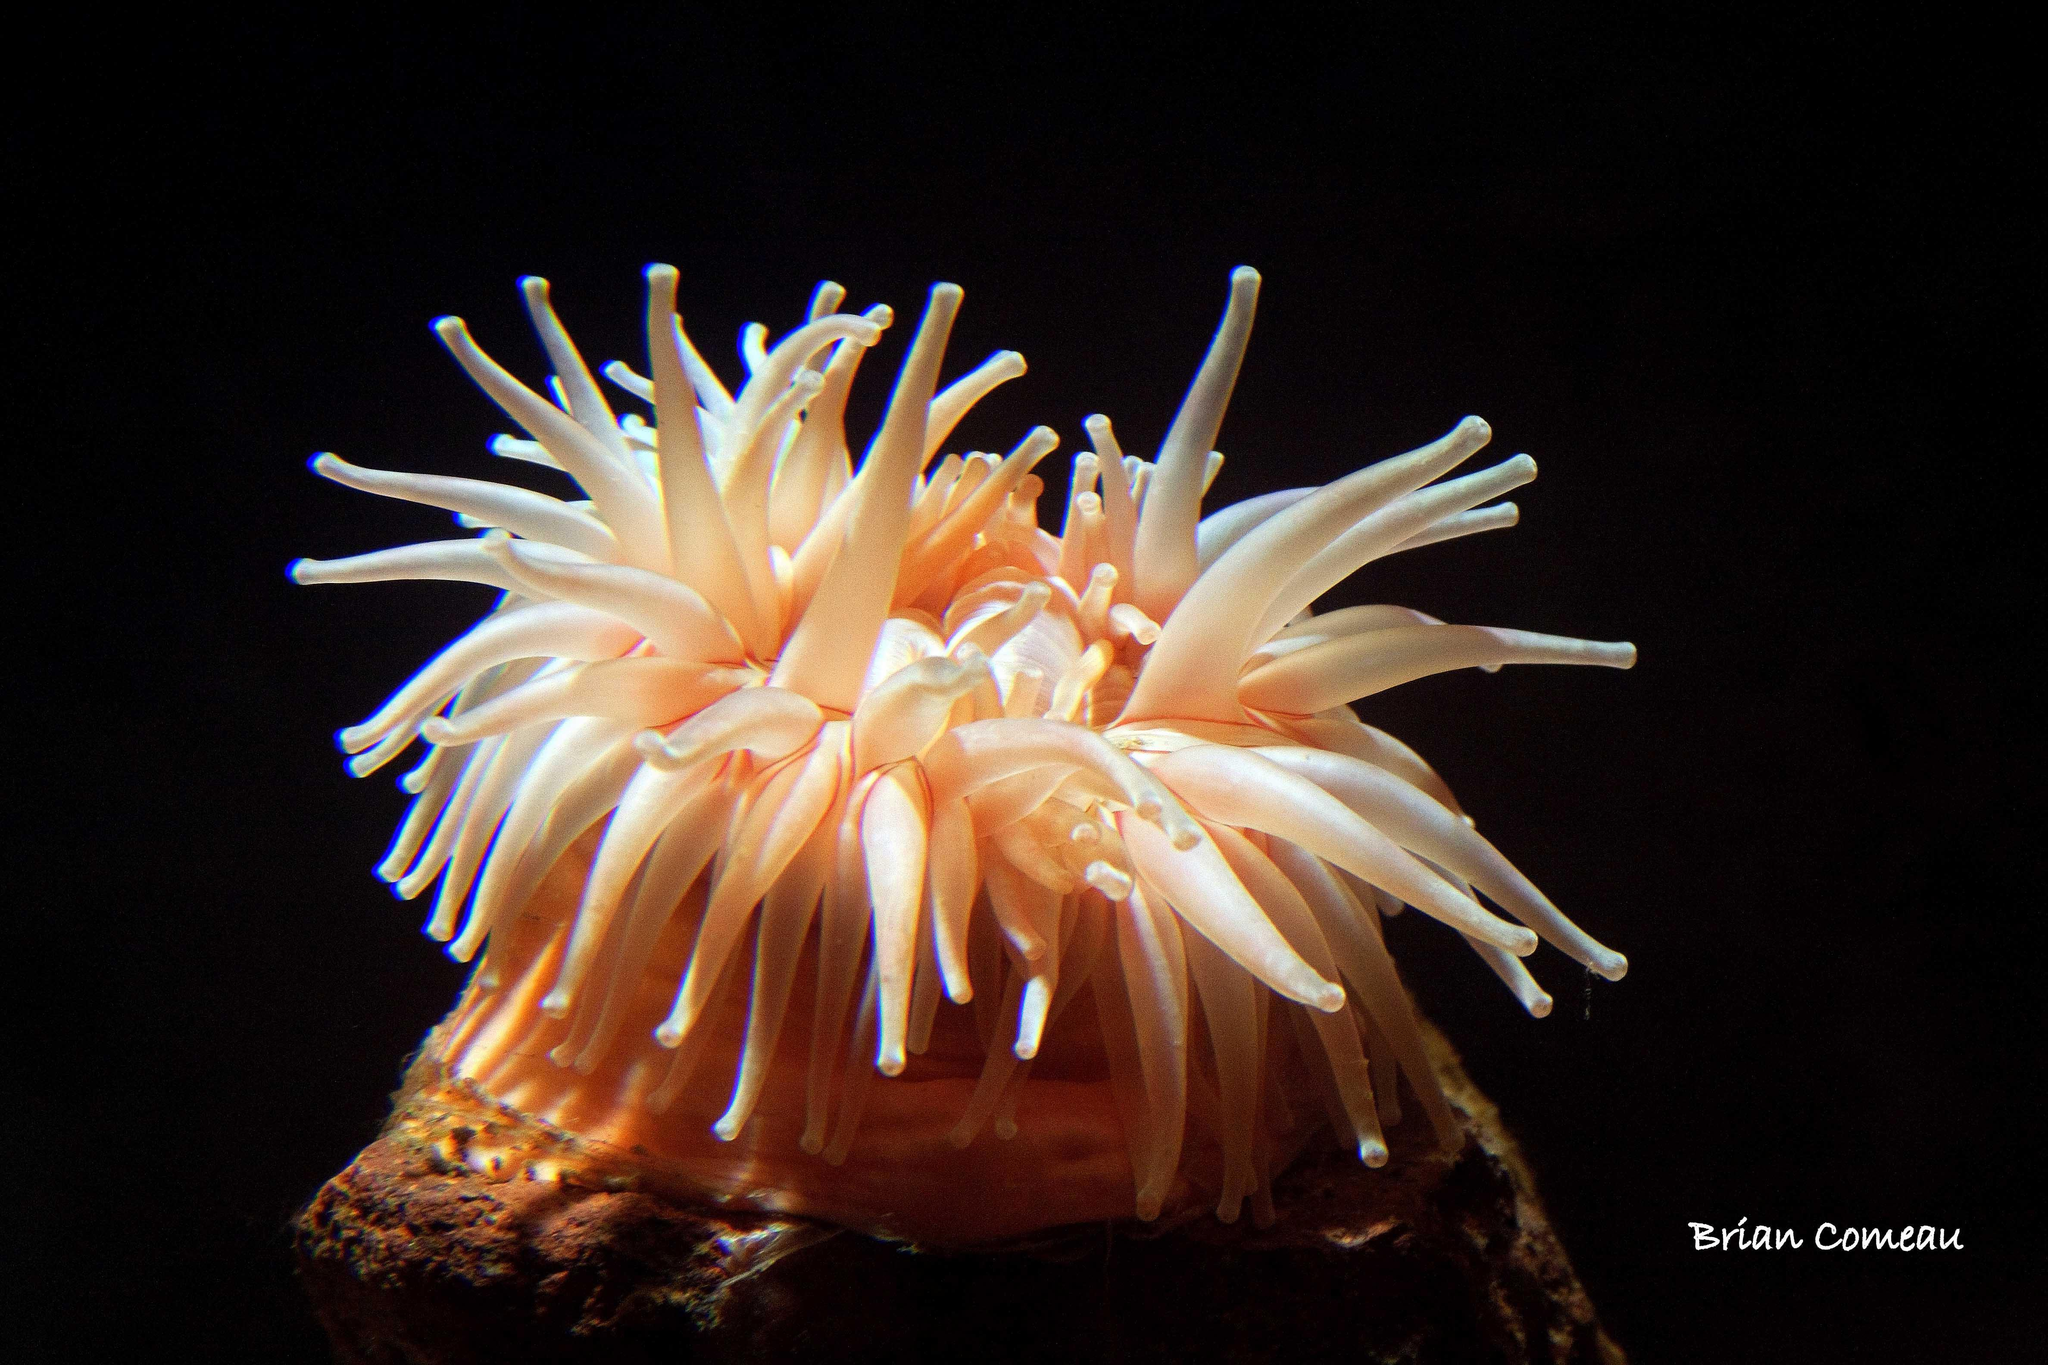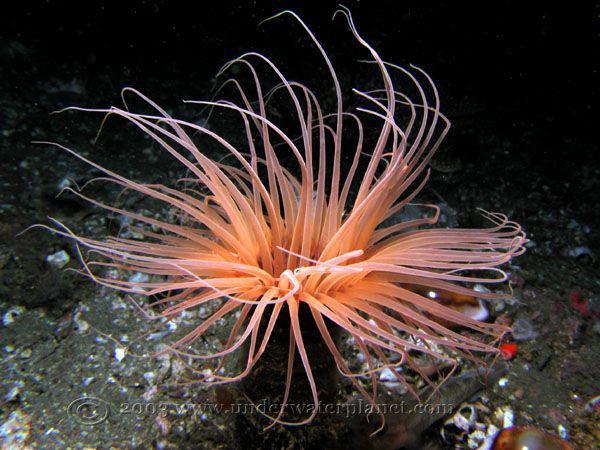The first image is the image on the left, the second image is the image on the right. Assess this claim about the two images: "One sea anemone has a visible mouth.". Correct or not? Answer yes or no. No. 